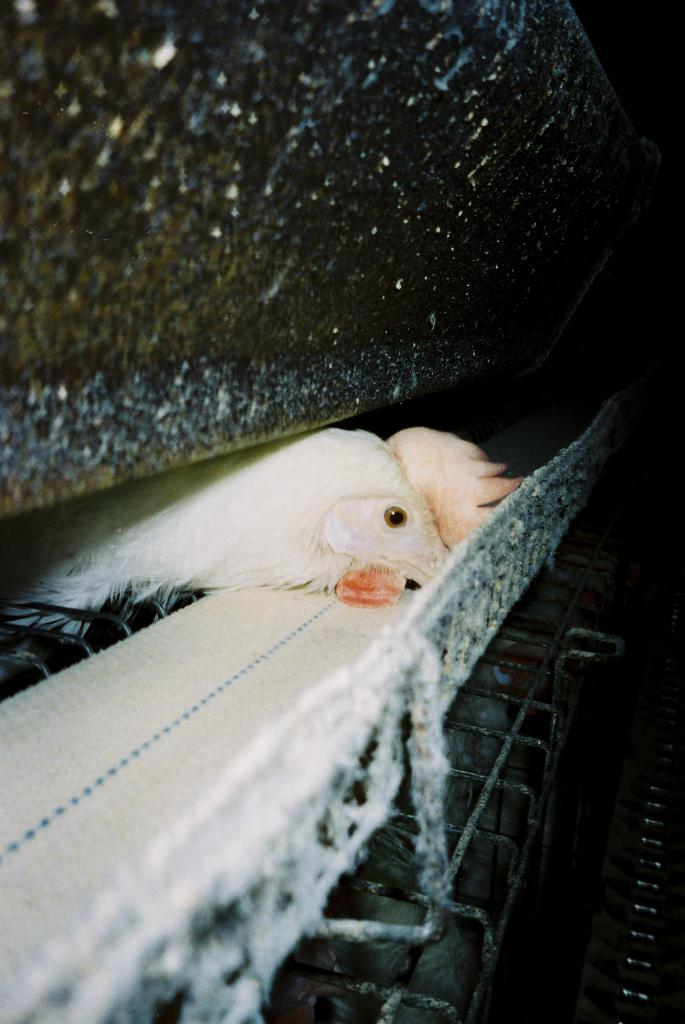What part of a hen is visible in the image? There is a hen's head in the image. What type of structure can be seen in the image? There is a wall in the image. What is the purpose of the iron stand in the image? The purpose of the iron stand in the image is not specified, but it could be used for holding or displaying objects. What type of mist can be seen surrounding the hen's head in the image? There is no mist present in the image; it only features a hen's head, a wall, and an iron stand. 